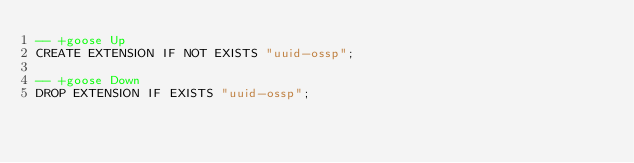<code> <loc_0><loc_0><loc_500><loc_500><_SQL_>-- +goose Up
CREATE EXTENSION IF NOT EXISTS "uuid-ossp";

-- +goose Down
DROP EXTENSION IF EXISTS "uuid-ossp";
</code> 